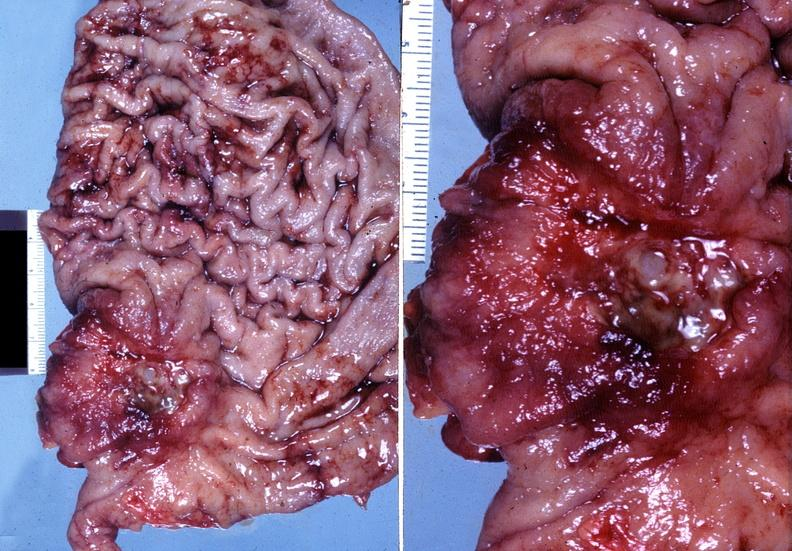what is present?
Answer the question using a single word or phrase. Gastrointestinal 